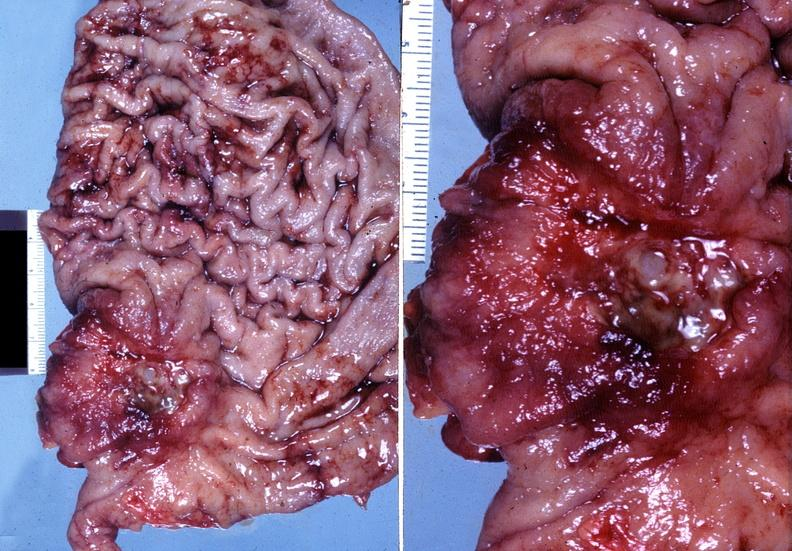what is present?
Answer the question using a single word or phrase. Gastrointestinal 